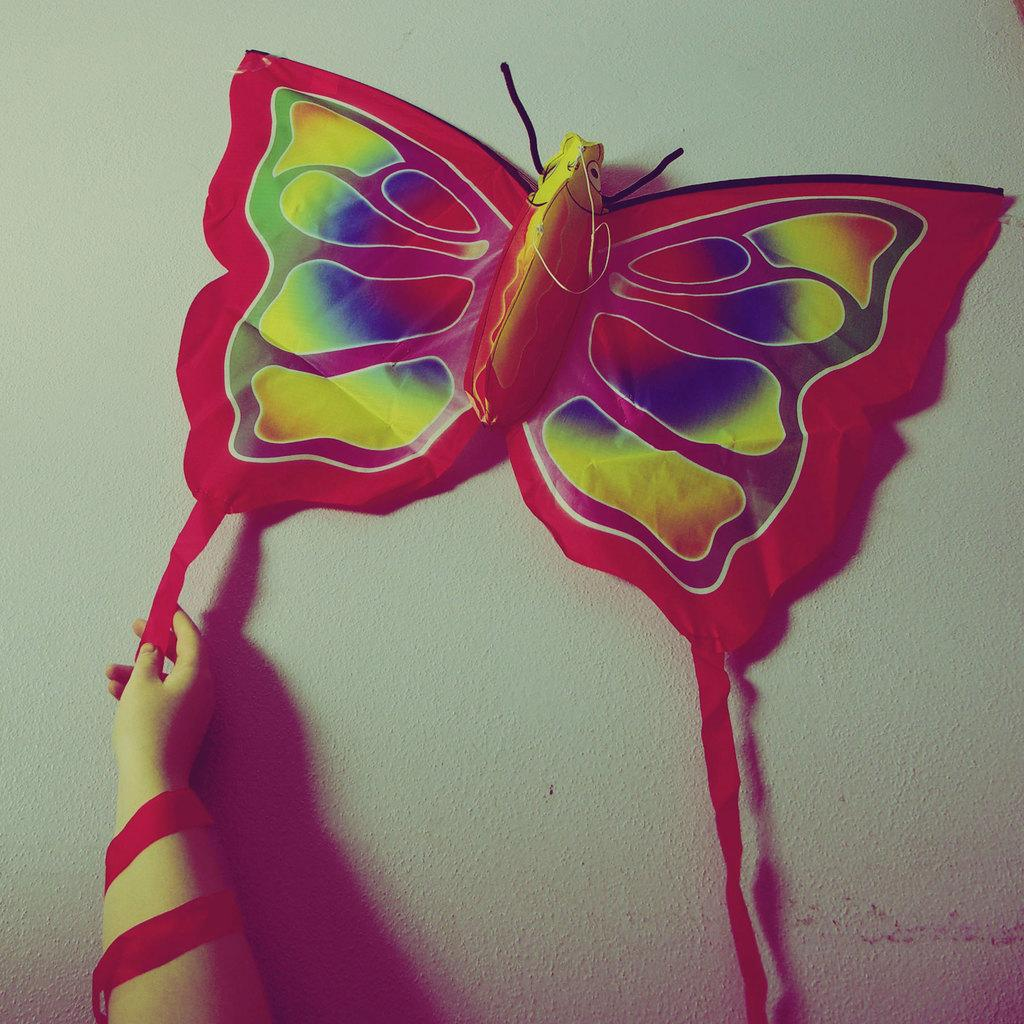What shape is the object on the wall in the image? The object on the wall in the image is butterfly-shaped. Can you describe the hand visible in the image? A person's hand is visible in the image. How many cherries are hanging from the butterfly-shaped object on the wall in the image? There are no cherries present in the image. Is there a bead attached to the person's hand visible in the image? There is no bead or any other object attached to the person's hand visible in the image. 